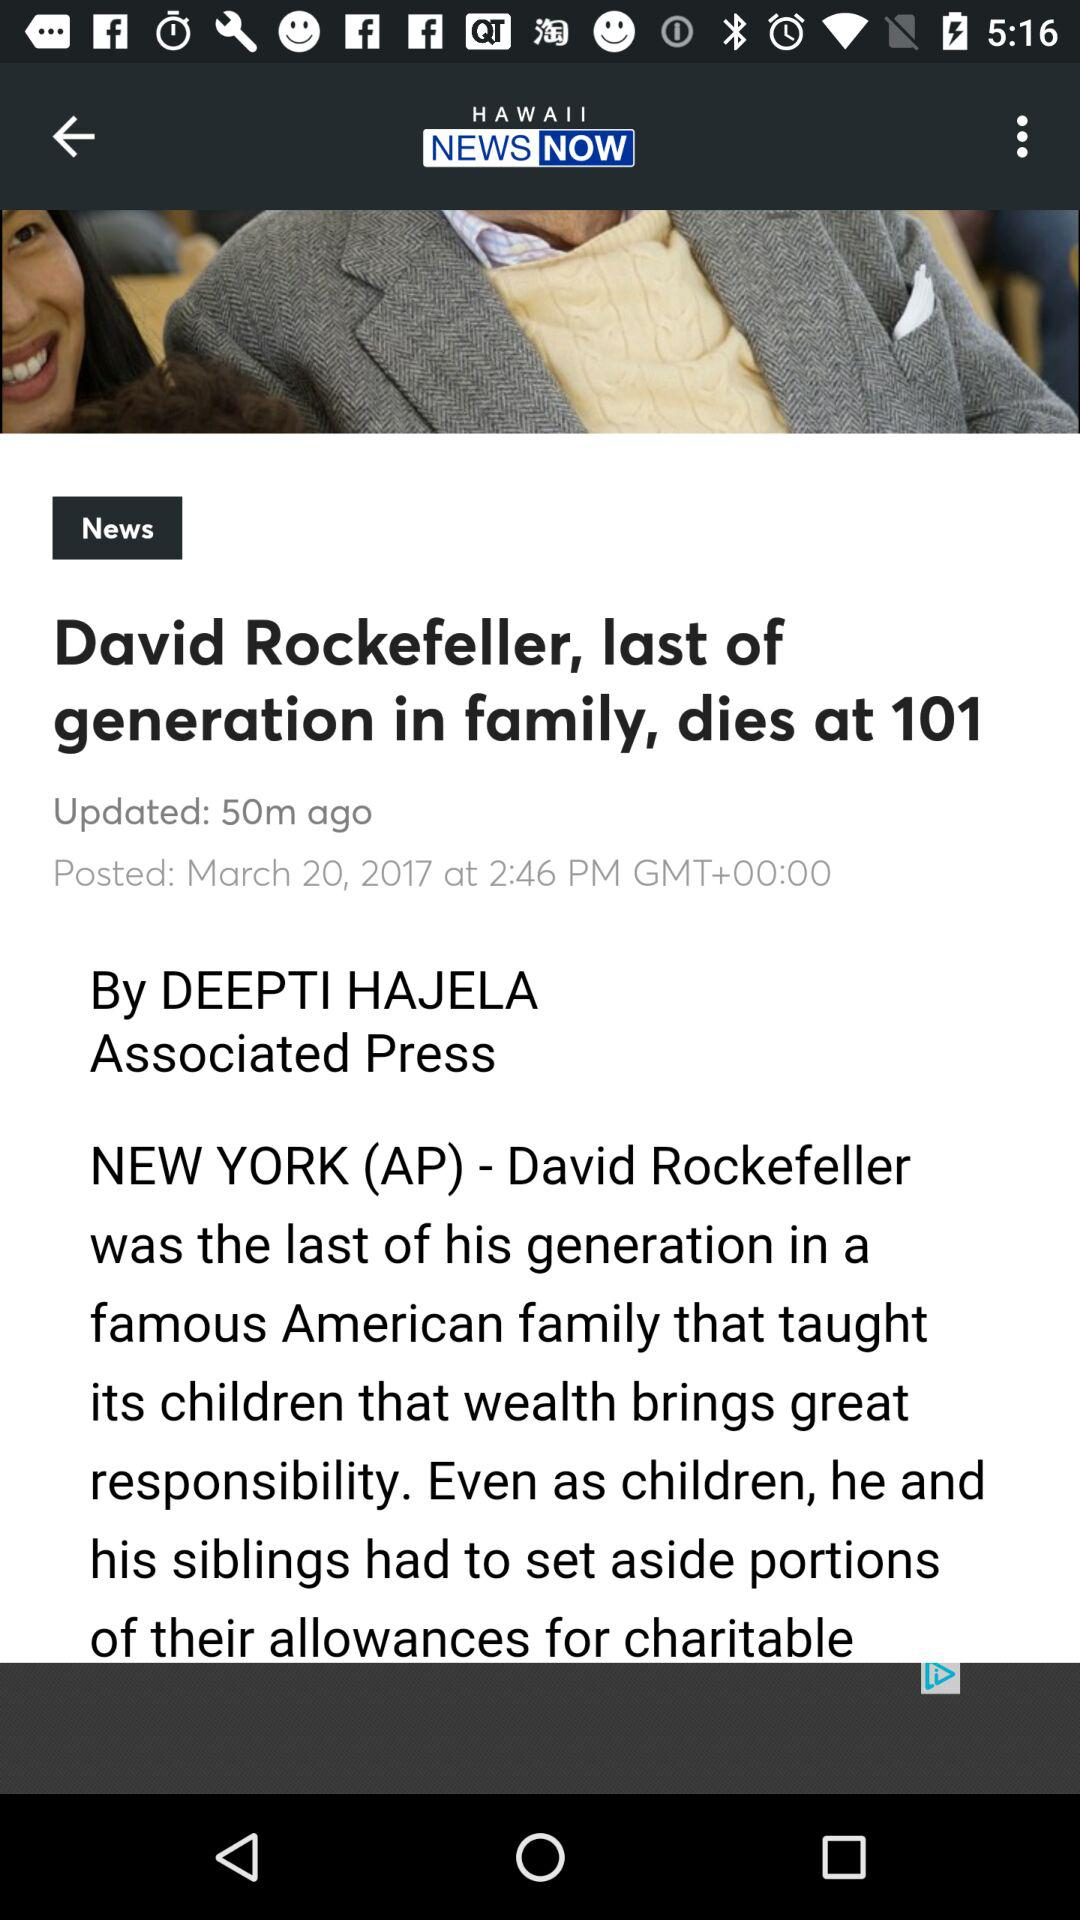Who is the writer of the news? The writer of the news is Deepti Hajela. 